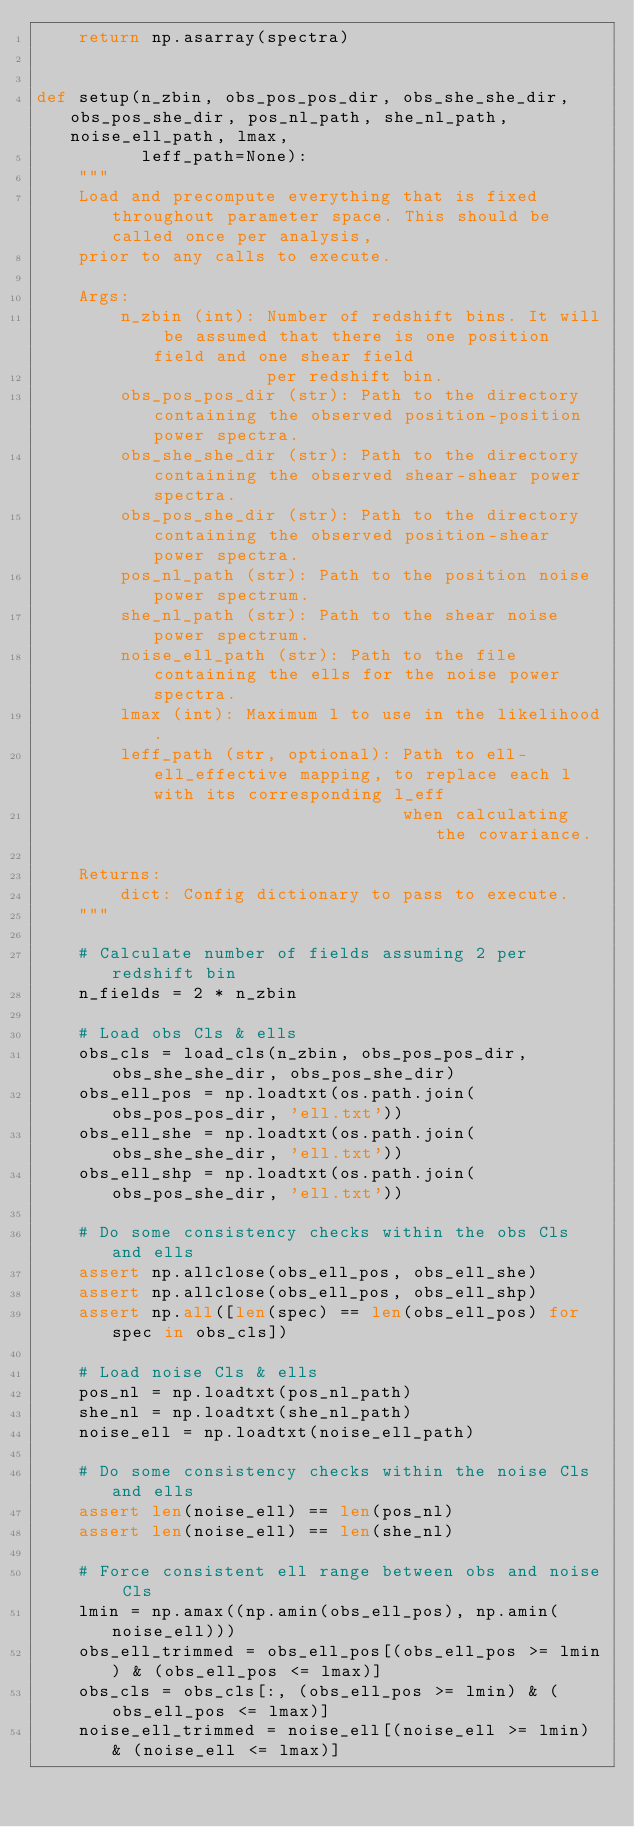<code> <loc_0><loc_0><loc_500><loc_500><_Python_>    return np.asarray(spectra)


def setup(n_zbin, obs_pos_pos_dir, obs_she_she_dir, obs_pos_she_dir, pos_nl_path, she_nl_path, noise_ell_path, lmax,
          leff_path=None):
    """
    Load and precompute everything that is fixed throughout parameter space. This should be called once per analysis,
    prior to any calls to execute.

    Args:
        n_zbin (int): Number of redshift bins. It will be assumed that there is one position field and one shear field
                      per redshift bin.
        obs_pos_pos_dir (str): Path to the directory containing the observed position-position power spectra.
        obs_she_she_dir (str): Path to the directory containing the observed shear-shear power spectra.
        obs_pos_she_dir (str): Path to the directory containing the observed position-shear power spectra.
        pos_nl_path (str): Path to the position noise power spectrum.
        she_nl_path (str): Path to the shear noise power spectrum.
        noise_ell_path (str): Path to the file containing the ells for the noise power spectra.
        lmax (int): Maximum l to use in the likelihood.
        leff_path (str, optional): Path to ell-ell_effective mapping, to replace each l with its corresponding l_eff
                                   when calculating the covariance.

    Returns:
        dict: Config dictionary to pass to execute.
    """

    # Calculate number of fields assuming 2 per redshift bin
    n_fields = 2 * n_zbin

    # Load obs Cls & ells
    obs_cls = load_cls(n_zbin, obs_pos_pos_dir, obs_she_she_dir, obs_pos_she_dir)
    obs_ell_pos = np.loadtxt(os.path.join(obs_pos_pos_dir, 'ell.txt'))
    obs_ell_she = np.loadtxt(os.path.join(obs_she_she_dir, 'ell.txt'))
    obs_ell_shp = np.loadtxt(os.path.join(obs_pos_she_dir, 'ell.txt'))

    # Do some consistency checks within the obs Cls and ells
    assert np.allclose(obs_ell_pos, obs_ell_she)
    assert np.allclose(obs_ell_pos, obs_ell_shp)
    assert np.all([len(spec) == len(obs_ell_pos) for spec in obs_cls])

    # Load noise Cls & ells
    pos_nl = np.loadtxt(pos_nl_path)
    she_nl = np.loadtxt(she_nl_path)
    noise_ell = np.loadtxt(noise_ell_path)

    # Do some consistency checks within the noise Cls and ells
    assert len(noise_ell) == len(pos_nl)
    assert len(noise_ell) == len(she_nl)

    # Force consistent ell range between obs and noise Cls
    lmin = np.amax((np.amin(obs_ell_pos), np.amin(noise_ell)))
    obs_ell_trimmed = obs_ell_pos[(obs_ell_pos >= lmin) & (obs_ell_pos <= lmax)]
    obs_cls = obs_cls[:, (obs_ell_pos >= lmin) & (obs_ell_pos <= lmax)]
    noise_ell_trimmed = noise_ell[(noise_ell >= lmin) & (noise_ell <= lmax)]</code> 